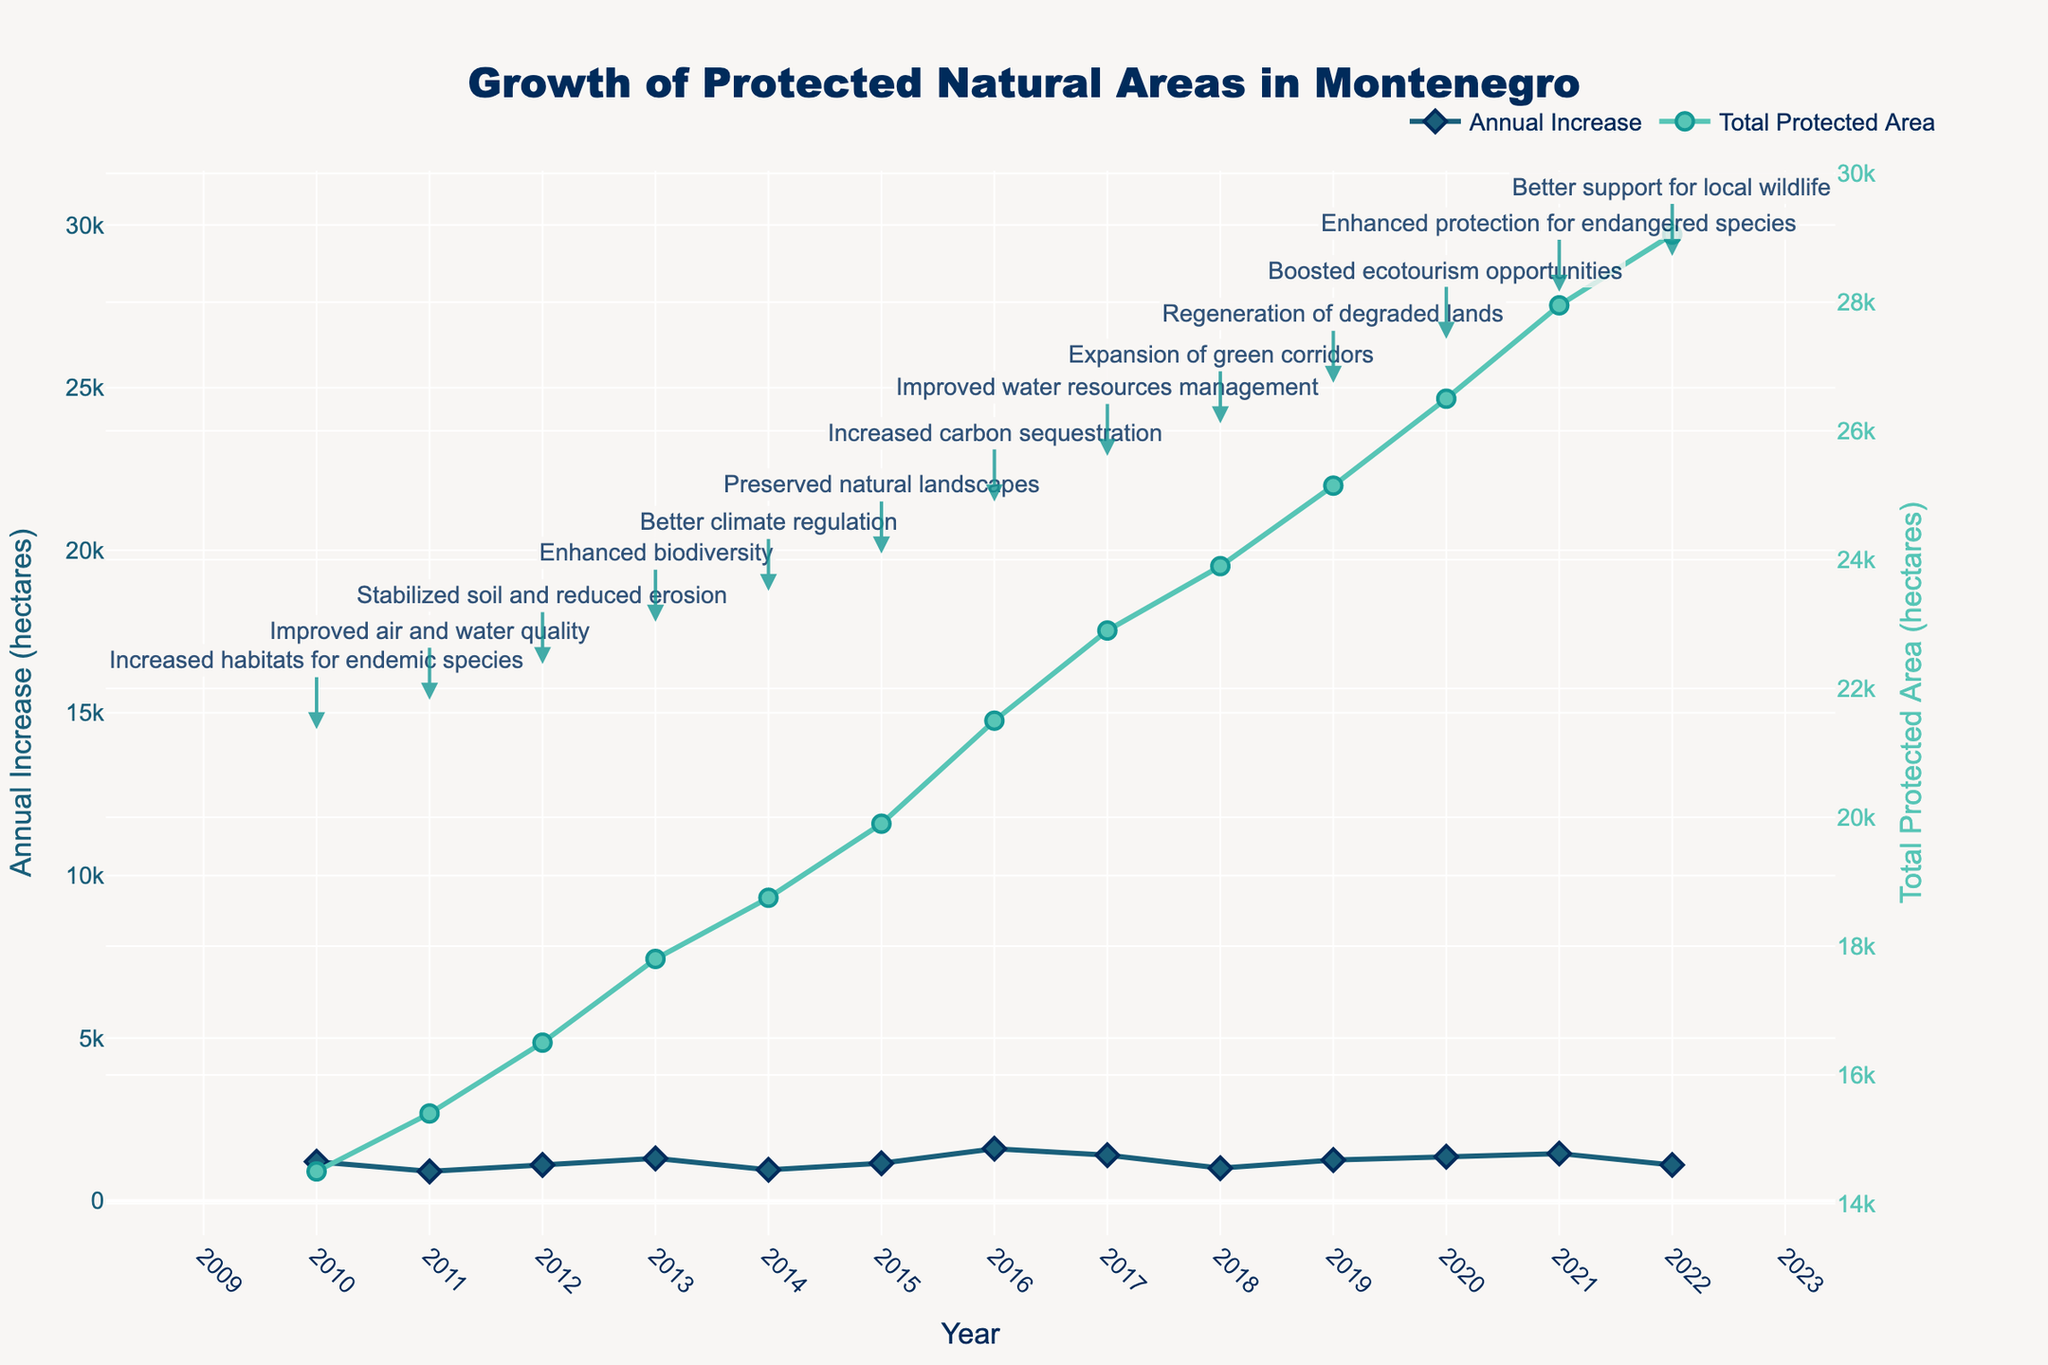What's the title of the plot? The title is usually found at the top of the plot. In this case, the plot's title is "Growth of Protected Natural Areas in Montenegro".
Answer: Growth of Protected Natural Areas in Montenegro How many years of data are presented in the plot? Count the distinct data points on the x-axis, representing unique years from 2010 to 2022.
Answer: 13 In which year was the annual increase in protected areas the highest? Look for the highest point on the "Annual Increase" line (the blue line). The highest point is in 2016.
Answer: 2016 What was the total protected area in Montenegro by the end of 2022? The right y-axis represents the total protected area. Look for the data point on the "Total Protected Area" line in 2022.
Answer: 29,050 hectares What main ecological impact was observed in 2013? Find the annotation for the year 2013 and read the main ecological impact noted in the plot.
Answer: Enhanced biodiversity How did the total protected area change from 2010 to 2015? Look at the "Total Protected Area" line from 2010 to 2015. The total protected area increased from 14,500 to 19,900 hectares. The change can be calculated as 19,900 - 14,500.
Answer: Increased by 5,400 hectares Which year saw the smallest annual increase in protected natural areas? Identify the lowest point on the "Annual Increase" line (the blue line). The smallest increase was in 2011.
Answer: 2011 Compare the total protected areas in 2014 and 2019. Which year had more protected area, and by how much? Identify the data points for 2014 and 2019 on the "Total Protected Area" line. 2014 had 18,750 hectares and 2019 had 25,150 hectares. Subtract 18,750 from 25,150 to find the difference.
Answer: 2019 by 6,400 hectares What trend can be observed in the annual ecological impact annotations over the years? Read through the yearly annotations. Each year, a different positive impact on the environment is noted, indicating a broad range of ecological benefits from preserving natural areas.
Answer: Diverse ecological benefits How much did the total protected area grow on average per year from 2010 to 2022? Calculate the average increase in total protected area. The starting point in 2010 is 14,500 hectares, and the endpoint in 2022 is 29,050 hectares. The period spans 12 years (from 2010 to 2022). The total increase is 29,050 - 14,500 = 14,550 hectares. Average increase per year is 14,550 / 12.
Answer: 1,212.5 hectares per year 